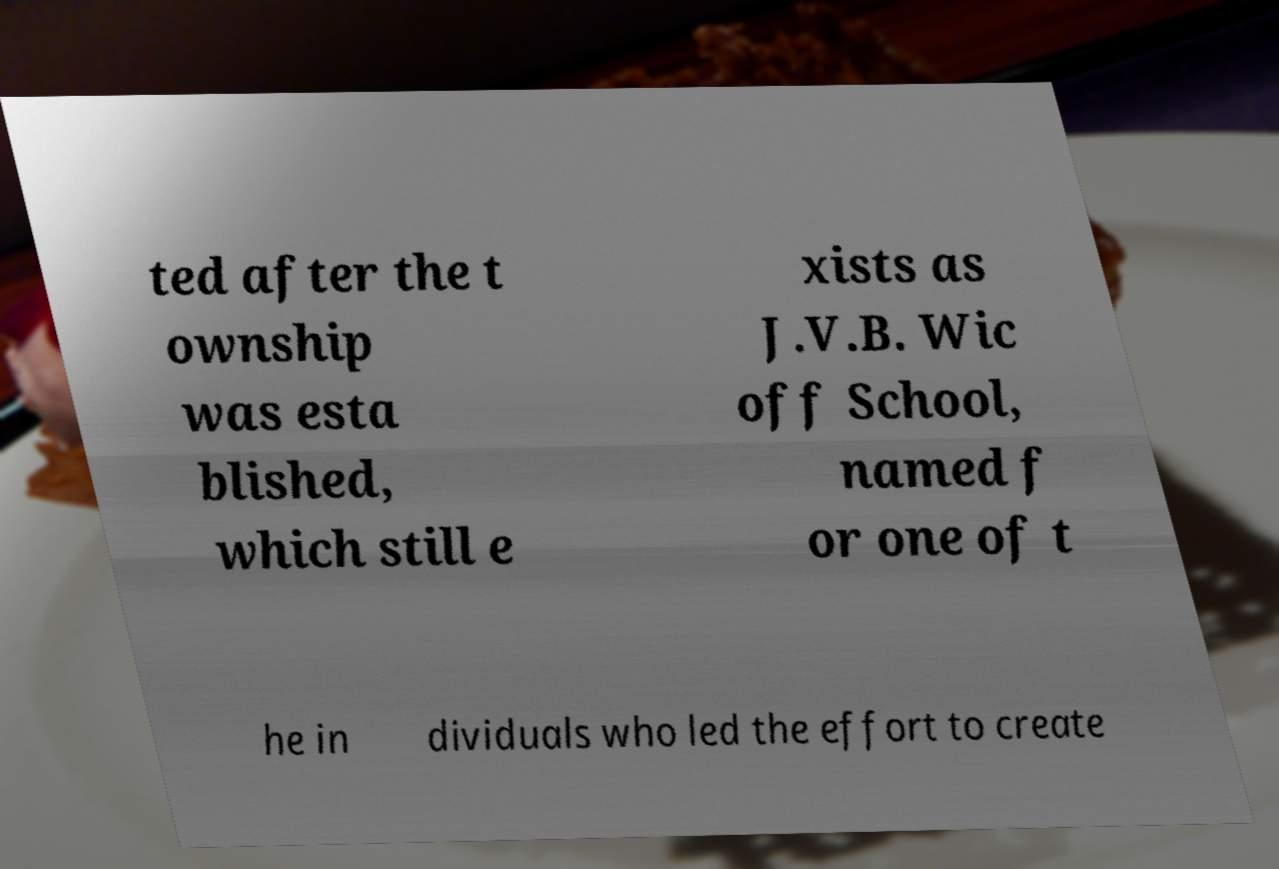Can you read and provide the text displayed in the image?This photo seems to have some interesting text. Can you extract and type it out for me? ted after the t ownship was esta blished, which still e xists as J.V.B. Wic off School, named f or one of t he in dividuals who led the effort to create 